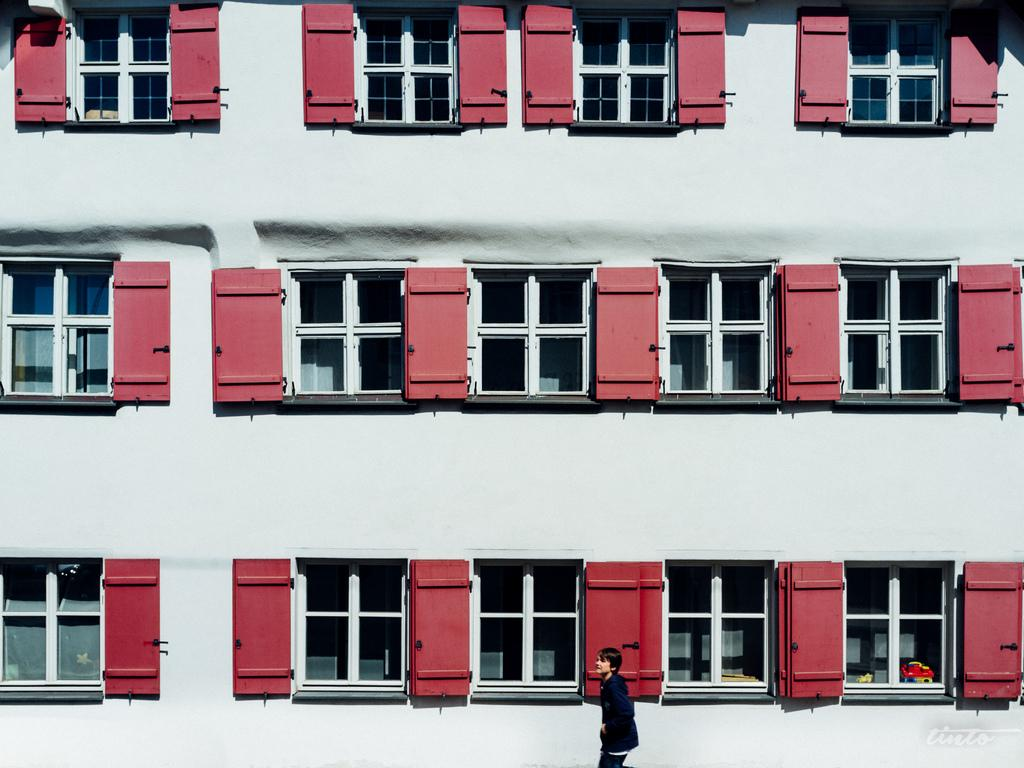What is the main structure in the image? There is a building in the image. What feature can be seen on the building? The building has windows. Can you describe the person in the image? There is a person at the bottom of the image. What type of hat is the person wearing in the image? There is no hat visible in the image; the person is not wearing one. What emotion can be seen on the person's face in the image? The provided facts do not mention any emotions or facial expressions, so it cannot be determined from the image. 